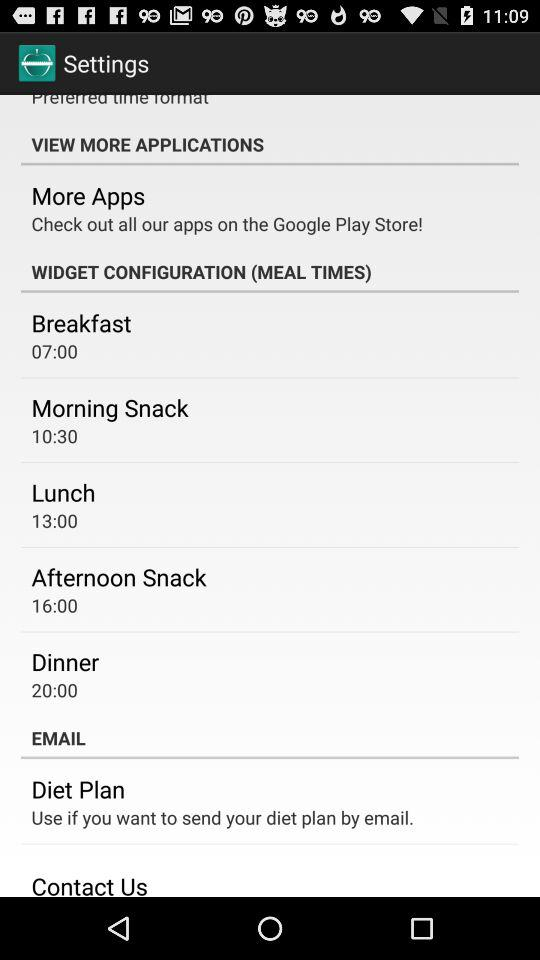What is dinner time? Dinner time is 20:00. 